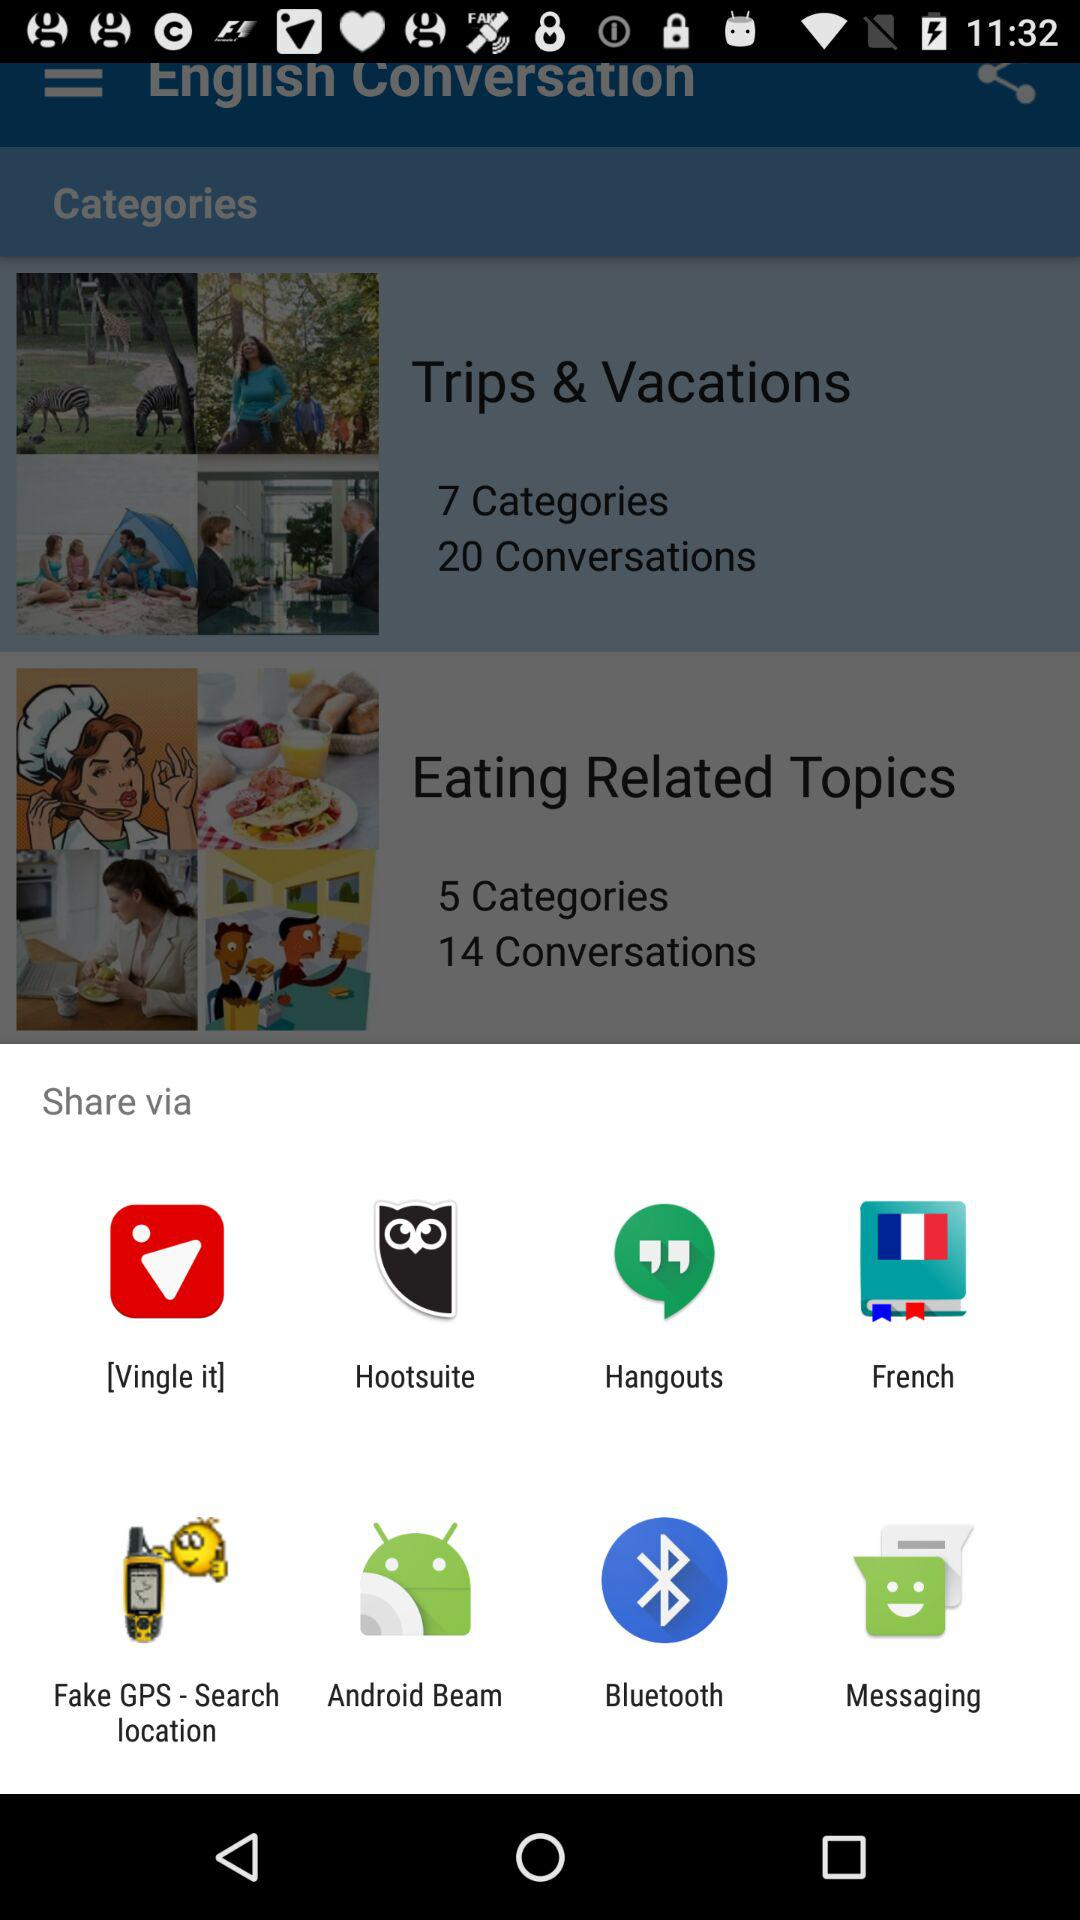What applications can be used to share? The applications that can be used to share are "Vingle", "Hootsuite", "Hangouts", "French", "Fake GPS - Search location", "Android Beam", "Bluetooth" and "Messaging". 